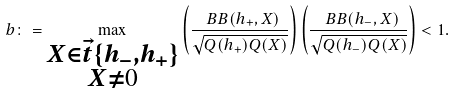Convert formula to latex. <formula><loc_0><loc_0><loc_500><loc_500>b \colon = \max _ { \substack { X \in \vec { t } \{ h _ { - } , h _ { + } \} \\ X \neq 0 } } \left ( \frac { \ B B ( h _ { + } , X ) } { \sqrt { Q ( h _ { + } ) Q ( X ) } } \right ) \left ( \frac { \ B B ( h _ { - } , X ) } { \sqrt { Q ( h _ { - } ) Q ( X ) } } \right ) < 1 .</formula> 